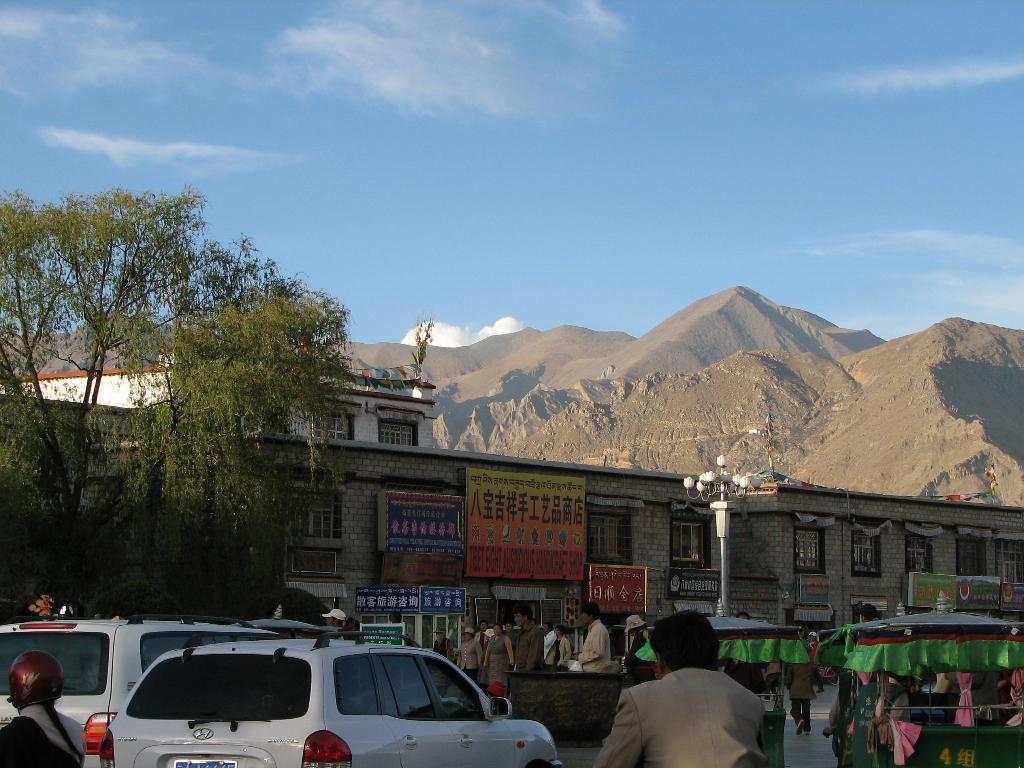What types of objects are present in the image? There are vehicles, people, tents, poles, trees, buildings, and mountains visible in the image. Can you describe the people in the image? The image shows people, but it does not provide specific details about them. What is the purpose of the poles on the road? The purpose of the poles on the road is not clear from the image, but they could be for traffic control or signage. What type of natural feature can be seen in the background of the image? Mountains are visible in the background of the image. Can you tell me how many owls are sitting on the swing in the image? There are no owls or swings present in the image. What decision did the people make in the image? The image does not provide any information about the people's decisions or actions. 